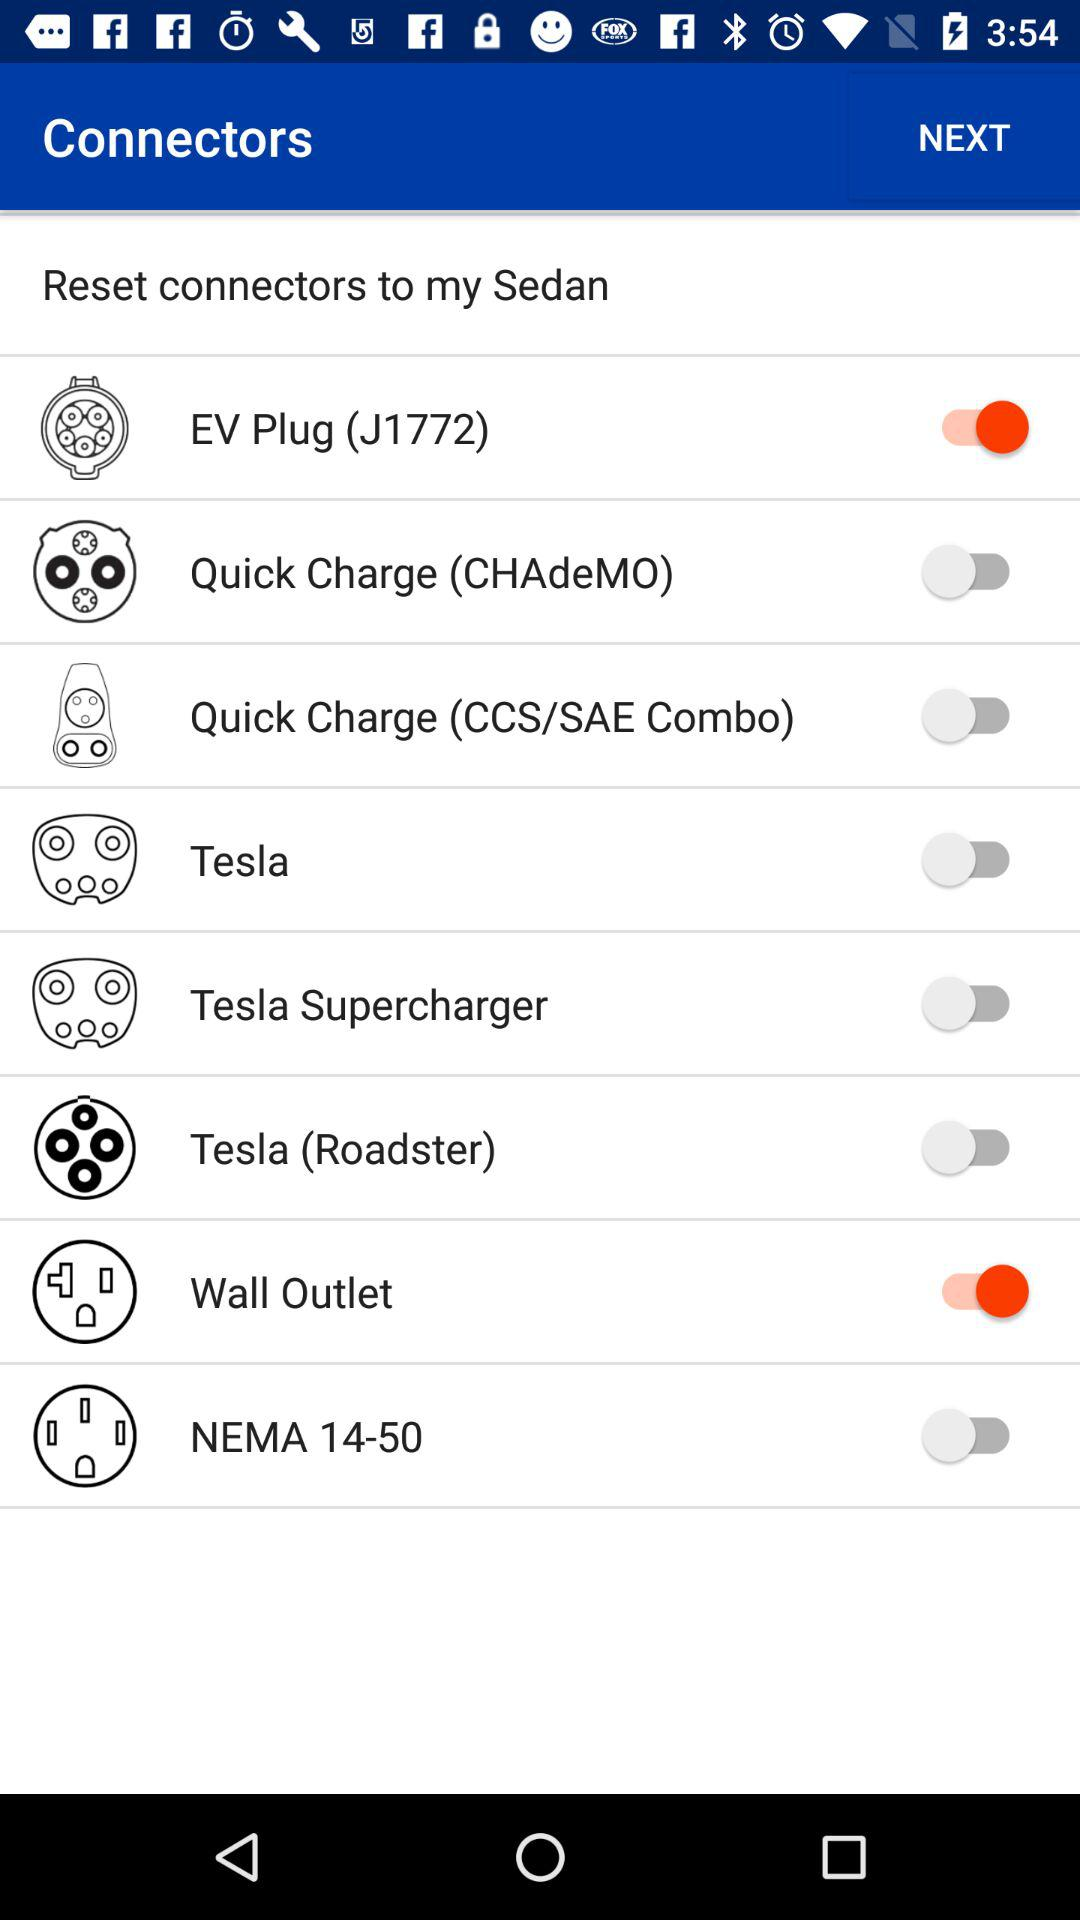How many more Tesla connectors are there than CHAdeMO connectors?
Answer the question using a single word or phrase. 2 